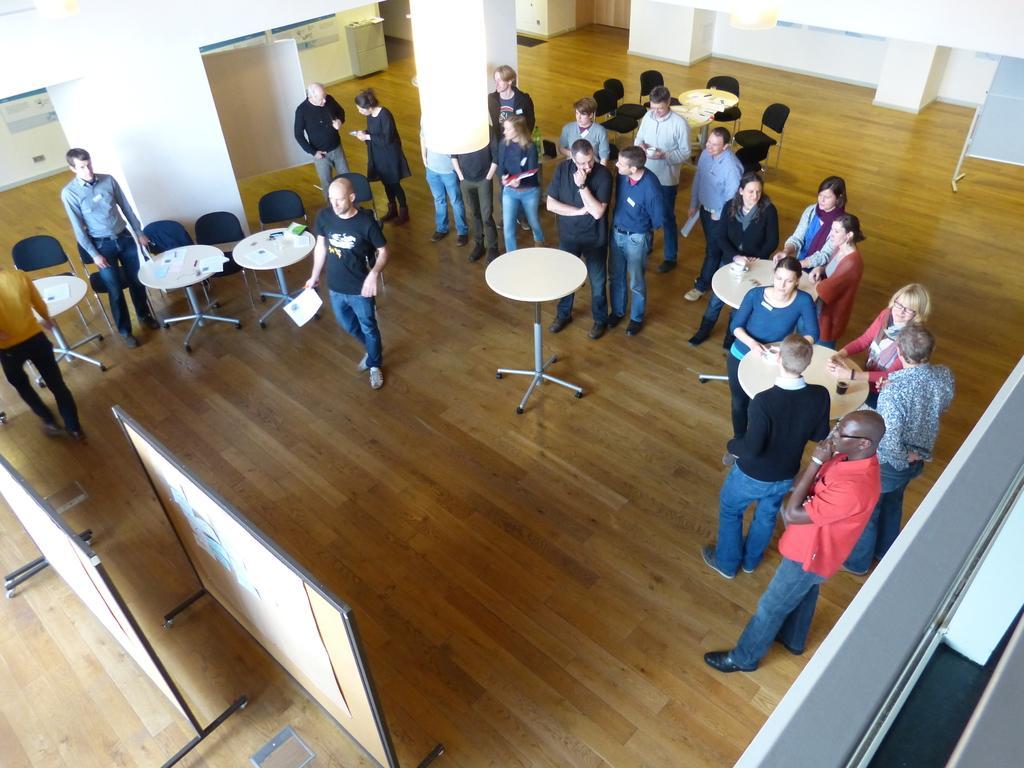Describe this image in one or two sentences. In this image i can see a number of persons standing on the floor ,in front of them there is a table and there are the boards on the floor ,on the back ground i can see there are the beams visible. And right corner i can see there are the chairs kept on the floor. 